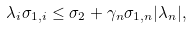Convert formula to latex. <formula><loc_0><loc_0><loc_500><loc_500>\lambda _ { i } \sigma _ { 1 , i } \leq \sigma _ { 2 } + \gamma _ { n } \sigma _ { 1 , n } | \lambda _ { n } | ,</formula> 